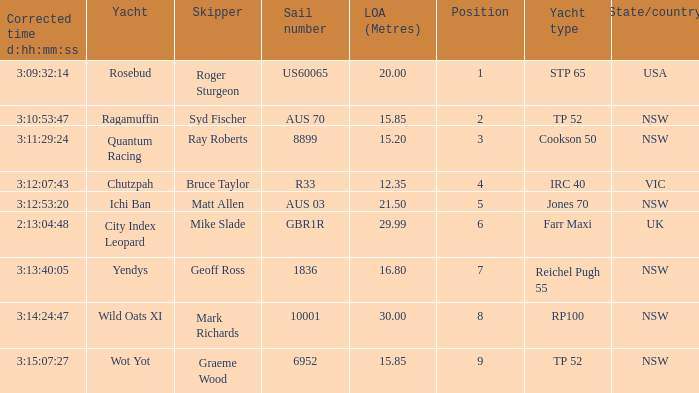How many yachts had a position of 3? 1.0. 